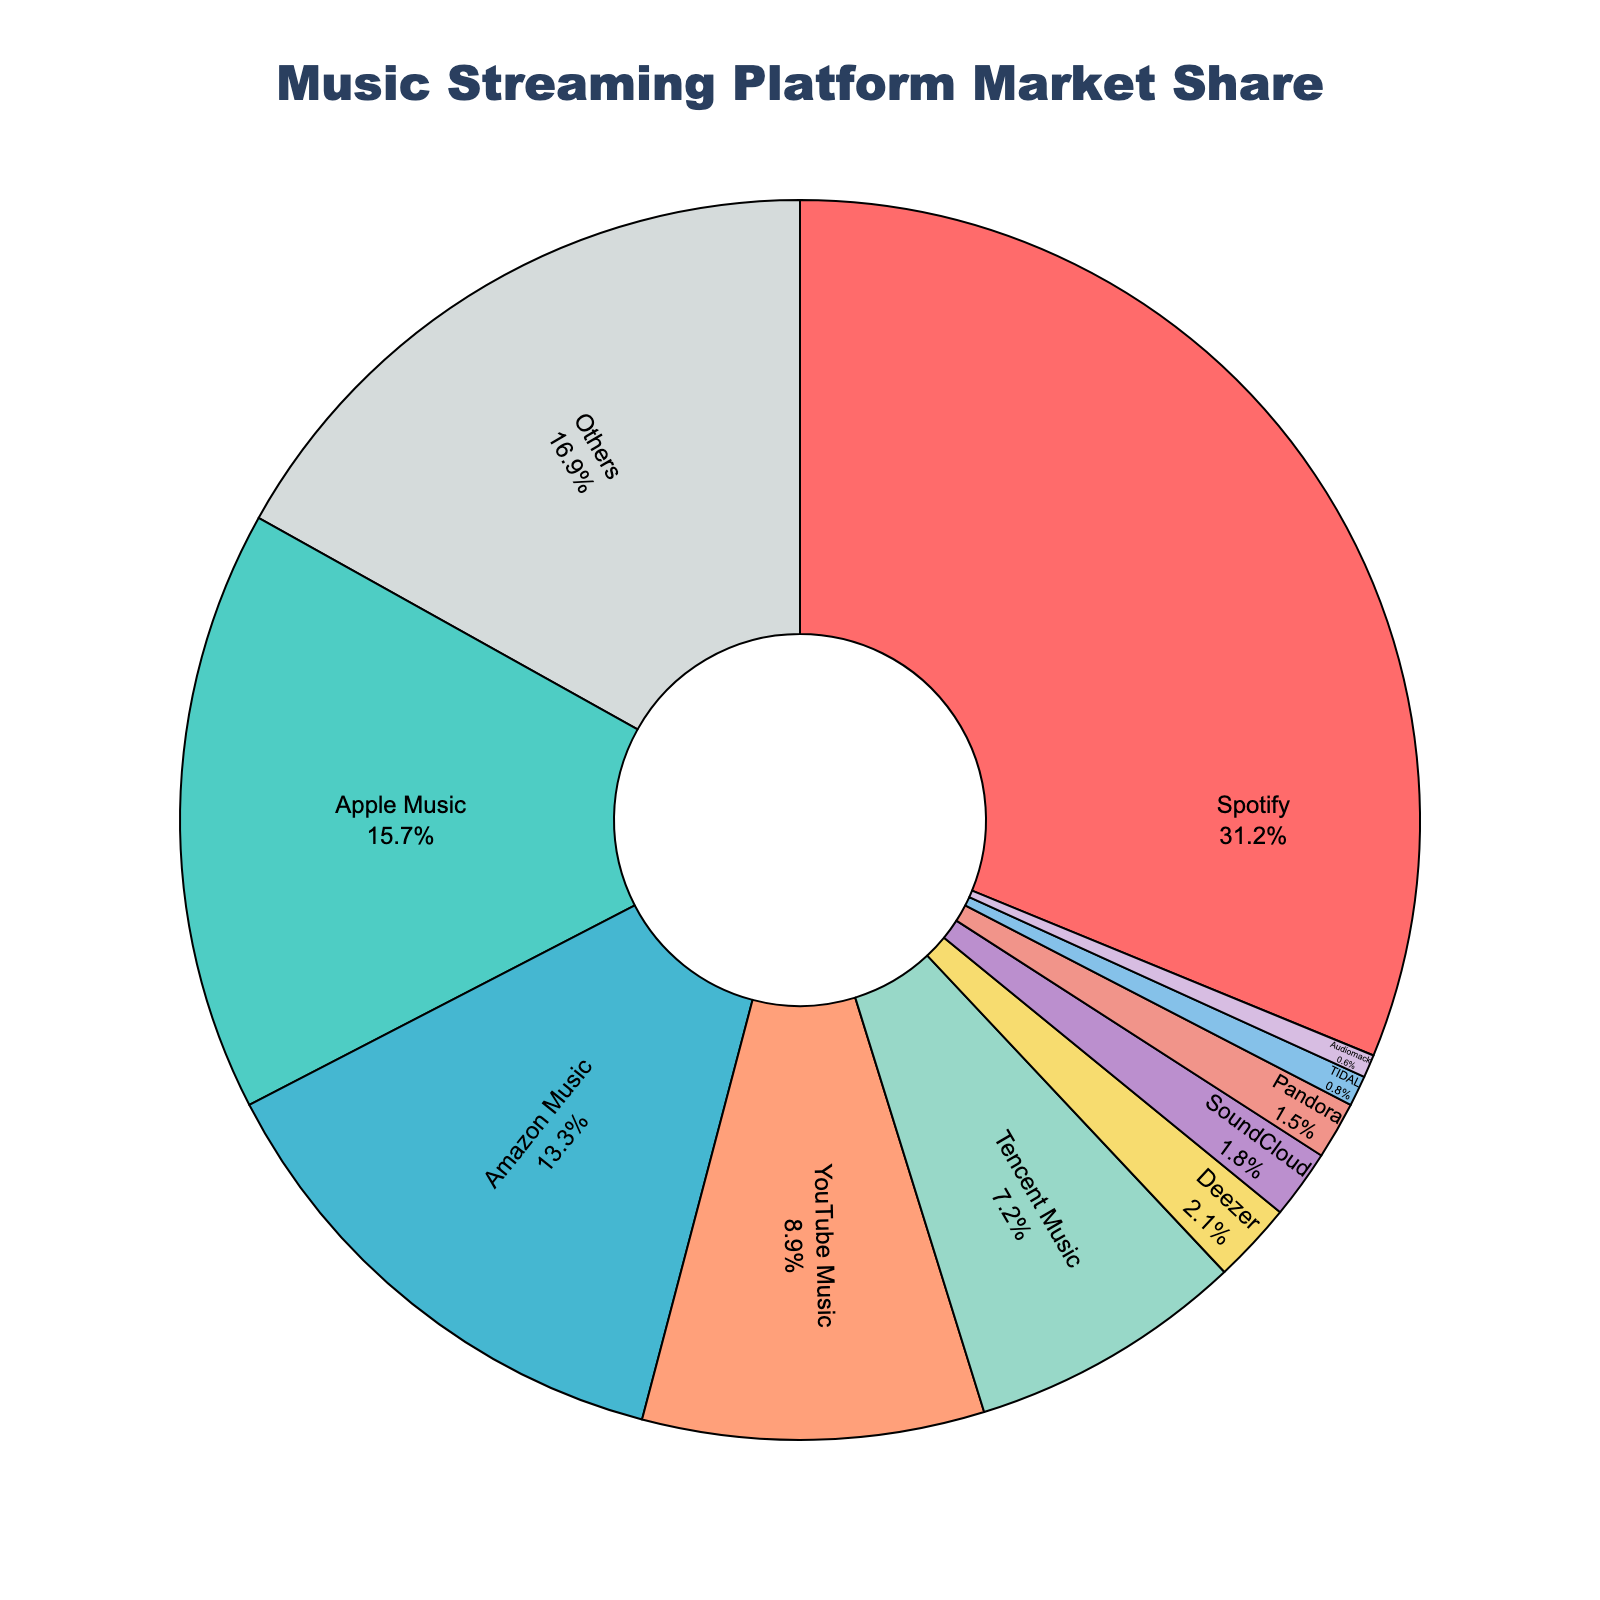What is the market share of Spotify? Spotify's market share is clearly labeled near the top of the pie chart.
Answer: 31.2% Which service has a lower market share, Apple Music or Amazon Music? Apple Music and Amazon Music's market shares are labeled. Apple Music has 15.7% and Amazon Music has 13.3%, so Amazon Music has a lower share.
Answer: Amazon Music How much greater is Spotify's market share compared to Pandora's? Spotify's market share is 31.2% and Pandora's is 1.5%. The difference is 31.2% - 1.5% = 29.7%.
Answer: 29.7% What is the combined market share of Spotify, Apple Music, and Amazon Music? Spotify has 31.2%, Apple Music has 15.7%, and Amazon Music has 13.3%. Adding them together: 31.2% + 15.7% + 13.3% = 60.2%.
Answer: 60.2% Which service holds a bigger market share: YouTube Music or Tencent Music? YouTube Music has 8.9% and Tencent Music has 7.2%, so YouTube Music holds a bigger share.
Answer: YouTube Music What percentage of the market is held by services with less than 2% share each? The services with less than 2% share are SoundCloud (1.8%), Pandora (1.5%), TIDAL (0.8%), and Audiomack (0.6%). Adding them together: 1.8% + 1.5% + 0.8% + 0.6% = 4.7%.
Answer: 4.7% What is the difference in market share between the leading service and the smallest listed service? The leading service is Spotify with 31.2% and the smallest listed service is Audiomack with 0.6%. The difference is 31.2% - 0.6% = 30.6%.
Answer: 30.6% If "Others" were not included, what would be the new combined market share of all the listed specific services? "Others" category is 16.9%. The combined market share is 100%, so excluding "Others": 100% - 16.9% = 83.1%.
Answer: 83.1% Which is the least popular service among the listed ones? The least popular service is the one with the smallest market share. Audiomack has the smallest share with 0.6%.
Answer: Audiomack How much more market share does Deezer have compared to TIDAL? Deezer has 2.1% and TIDAL has 0.8%. The difference is 2.1% - 0.8% = 1.3%.
Answer: 1.3% 